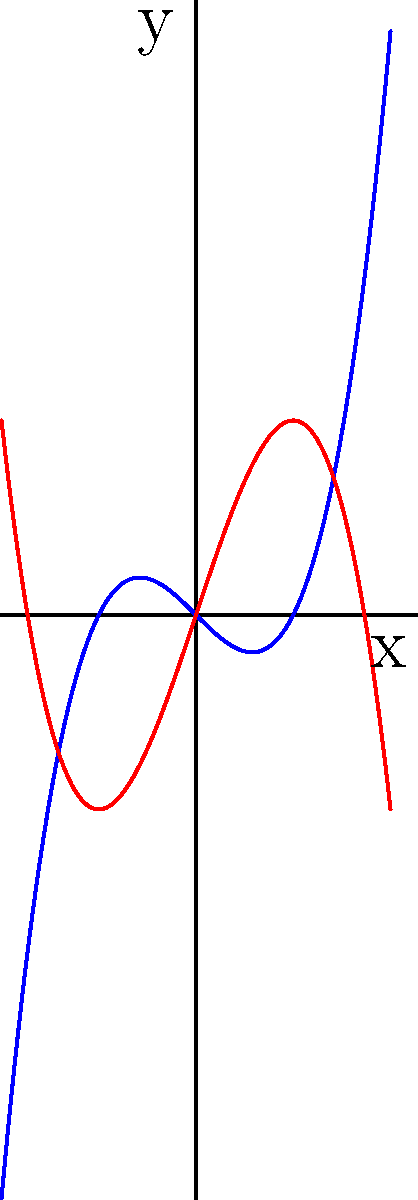Consider the two polynomial functions graphed above: $f(x) = x^3 - x$ (blue) and $g(x) = -x^3 + 3x$ (red). Which function has the greater rate of change at $x = 1$, and what does this imply about the behavior of these functions for large positive values of $x$? Let's approach this step-by-step:

1) To compare the rate of change at $x = 1$, we need to find the derivative of each function and evaluate it at $x = 1$.

2) For $f(x) = x^3 - x$:
   $f'(x) = 3x^2 - 1$
   At $x = 1$: $f'(1) = 3(1)^2 - 1 = 2$

3) For $g(x) = -x^3 + 3x$:
   $g'(x) = -3x^2 + 3$
   At $x = 1$: $g'(1) = -3(1)^2 + 3 = 0$

4) We can see that $f'(1) > g'(1)$, so $f(x)$ has a greater rate of change at $x = 1$.

5) For large positive values of $x$, we need to consider the leading terms:
   For $f(x)$, the leading term is $x^3$ (positive)
   For $g(x)$, the leading term is $-x^3$ (negative)

6) This means that as $x$ approaches positive infinity, $f(x)$ will approach positive infinity, while $g(x)$ will approach negative infinity.

Therefore, $f(x)$ has a greater rate of change at $x = 1$, and for large positive $x$ values, $f(x)$ will grow much faster in the positive direction compared to $g(x)$, which will decrease rapidly in the negative direction.
Answer: $f(x)$ has the greater rate of change at $x = 1$. For large positive $x$, $f(x)$ grows positively while $g(x)$ decreases negatively. 